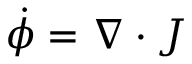<formula> <loc_0><loc_0><loc_500><loc_500>\dot { \phi } = \nabla \cdot J</formula> 